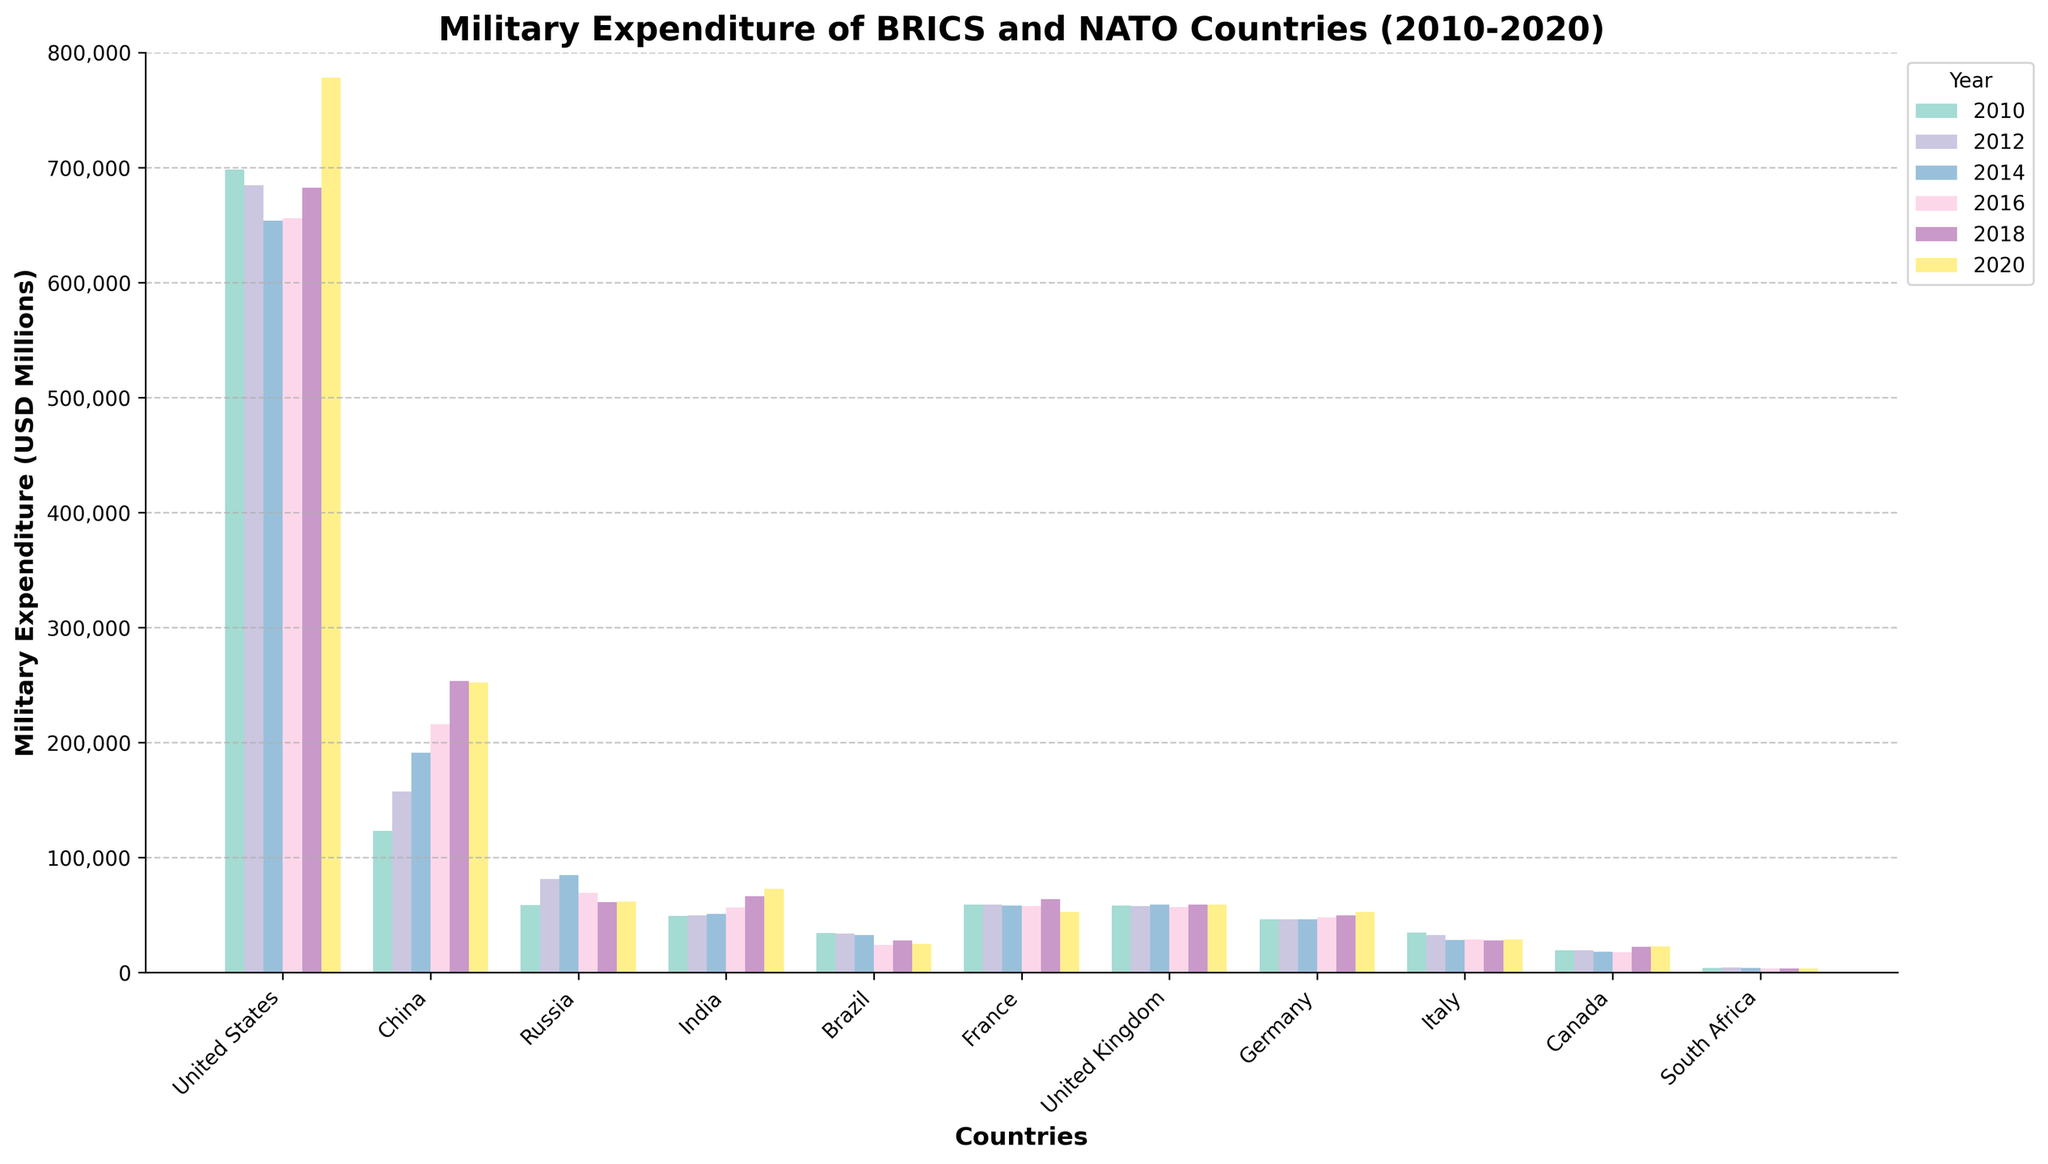What country has the highest military expenditure in 2018? Look for the tallest bar in the year 2018 across all the countries. The tallest bar belongs to the United States.
Answer: United States Which country had the greatest decrease in military expenditure from 2010 to 2020? Compare the heights of the bars for 2010 and 2020 for each country to find where the difference is largest. Italy had the most significant decrease from 34,760 in 2010 to 28,921 in 2020.
Answer: Italy How did India's military expenditure change from 2010 to 2020? Note the height of India's bar in 2010 and compare it to the height in 2020. The expenditure increased from 49,159 in 2010 to 72,890 in 2020.
Answer: Increased What is the total military expenditure of BRICS countries in 2014? Sum the heights of the bars for Brazil, Russia, India, China, and South Africa in the year 2014. The values are 32,660 (Brazil) + 84,697 (Russia) + 50,914 (India) + 190,974 (China) + 4,095 (South Africa) = 363,340.
Answer: 363,340 Which year did Russia have the highest military expenditure and what was the amount? Look for the tallest bar among the years for Russia and note the year and the corresponding value. The highest expenditure was in 2014 at 84,697.
Answer: 2014, 84,697 Compare the military expenditures of the United Kingdom and France in 2020. Which one is higher? Look at the heights of the bars for the United Kingdom and France in the year 2020. The United Kingdom's expenditure is 59,238, while France's expenditure is 52,747. The United Kingdom's expenditure is higher.
Answer: United Kingdom Average the military expenditures of South Africa from 2010 to 2020. Sum the military expenditures of South Africa for the years 2010, 2012, 2014, 2016, 2018, and 2020, which are 4,029 + 4,482 + 4,095 + 3,582 + 3,621 + 3,429 = 23,238. Then, divide by the number of years (6). 23,238 / 6 = 3,873.
Answer: 3,873 What is the trend in military expenditure for China from 2010 to 2020? Observe the heights of the bars for China from 2010 to 2020. The bars progressively increase from 123,338 in 2010, to peak at 253,491 in 2018, followed by a slight decrease to 252,304 in 2020.
Answer: Increasing By how much did the United States increase its military expenditure from 2016 to 2020? Subtract the military expenditure in 2016 from that in 2020 for the United States. The values are 778,232 (2020) - 656,059 (2016) = 122,173.
Answer: 122,173 